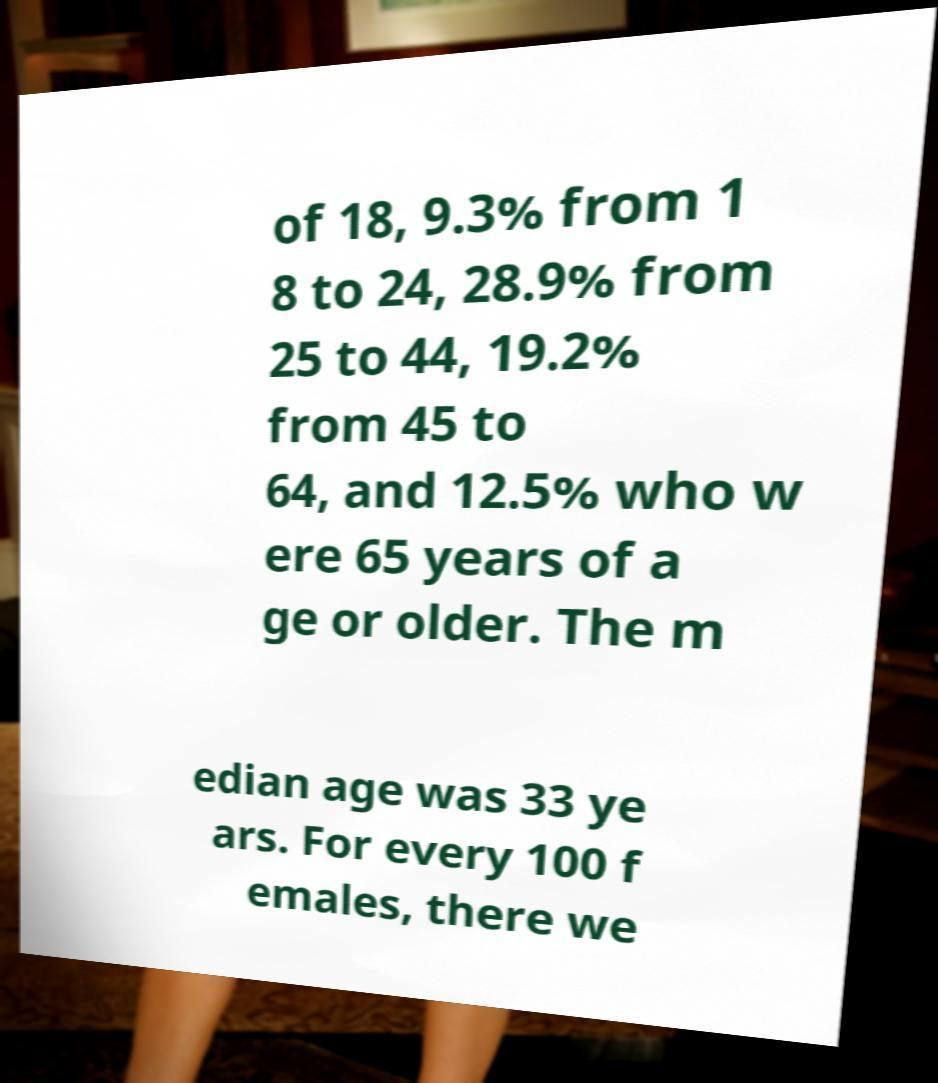Can you read and provide the text displayed in the image?This photo seems to have some interesting text. Can you extract and type it out for me? of 18, 9.3% from 1 8 to 24, 28.9% from 25 to 44, 19.2% from 45 to 64, and 12.5% who w ere 65 years of a ge or older. The m edian age was 33 ye ars. For every 100 f emales, there we 